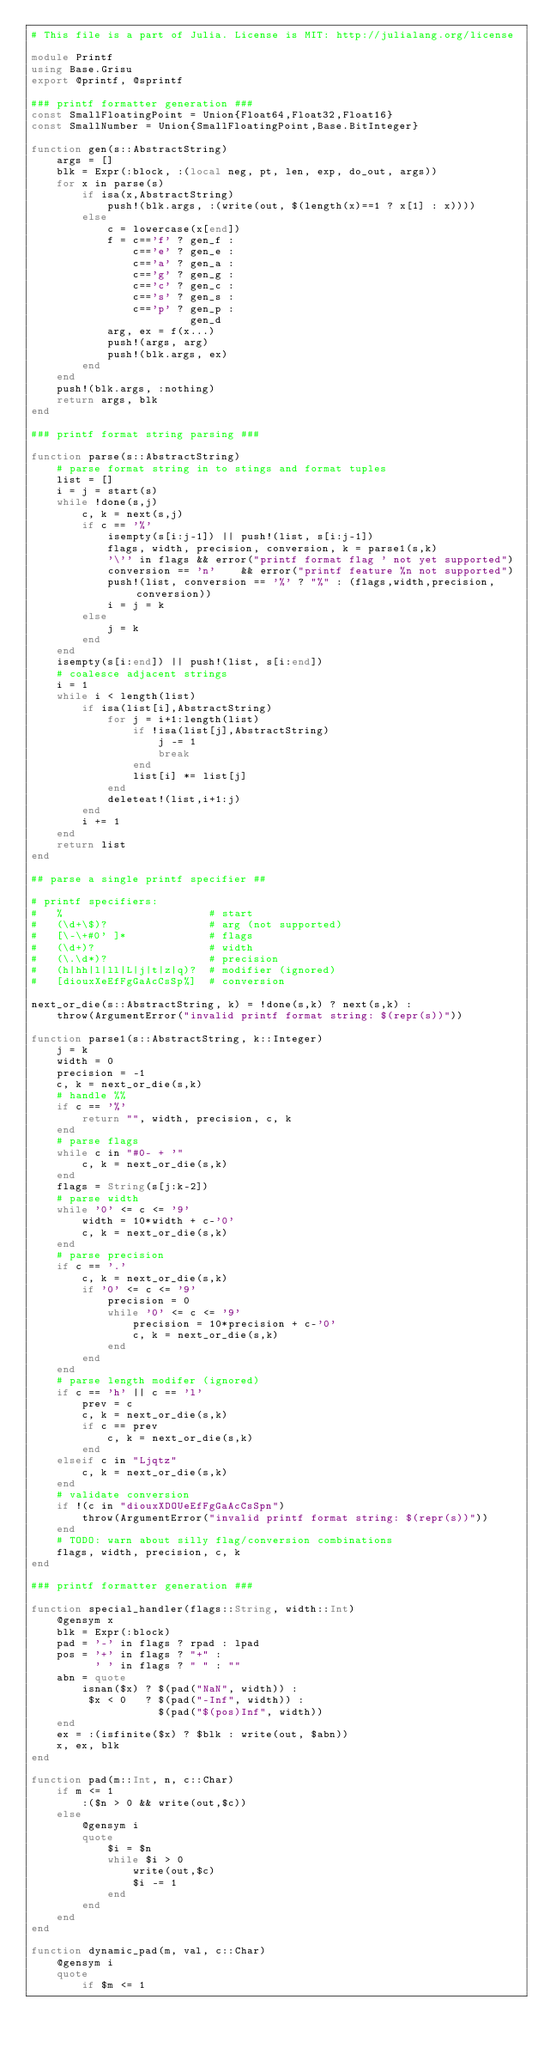<code> <loc_0><loc_0><loc_500><loc_500><_Julia_># This file is a part of Julia. License is MIT: http://julialang.org/license

module Printf
using Base.Grisu
export @printf, @sprintf

### printf formatter generation ###
const SmallFloatingPoint = Union{Float64,Float32,Float16}
const SmallNumber = Union{SmallFloatingPoint,Base.BitInteger}

function gen(s::AbstractString)
    args = []
    blk = Expr(:block, :(local neg, pt, len, exp, do_out, args))
    for x in parse(s)
        if isa(x,AbstractString)
            push!(blk.args, :(write(out, $(length(x)==1 ? x[1] : x))))
        else
            c = lowercase(x[end])
            f = c=='f' ? gen_f :
                c=='e' ? gen_e :
                c=='a' ? gen_a :
                c=='g' ? gen_g :
                c=='c' ? gen_c :
                c=='s' ? gen_s :
                c=='p' ? gen_p :
                         gen_d
            arg, ex = f(x...)
            push!(args, arg)
            push!(blk.args, ex)
        end
    end
    push!(blk.args, :nothing)
    return args, blk
end

### printf format string parsing ###

function parse(s::AbstractString)
    # parse format string in to stings and format tuples
    list = []
    i = j = start(s)
    while !done(s,j)
        c, k = next(s,j)
        if c == '%'
            isempty(s[i:j-1]) || push!(list, s[i:j-1])
            flags, width, precision, conversion, k = parse1(s,k)
            '\'' in flags && error("printf format flag ' not yet supported")
            conversion == 'n'    && error("printf feature %n not supported")
            push!(list, conversion == '%' ? "%" : (flags,width,precision,conversion))
            i = j = k
        else
            j = k
        end
    end
    isempty(s[i:end]) || push!(list, s[i:end])
    # coalesce adjacent strings
    i = 1
    while i < length(list)
        if isa(list[i],AbstractString)
            for j = i+1:length(list)
                if !isa(list[j],AbstractString)
                    j -= 1
                    break
                end
                list[i] *= list[j]
            end
            deleteat!(list,i+1:j)
        end
        i += 1
    end
    return list
end

## parse a single printf specifier ##

# printf specifiers:
#   %                       # start
#   (\d+\$)?                # arg (not supported)
#   [\-\+#0' ]*             # flags
#   (\d+)?                  # width
#   (\.\d*)?                # precision
#   (h|hh|l|ll|L|j|t|z|q)?  # modifier (ignored)
#   [diouxXeEfFgGaAcCsSp%]  # conversion

next_or_die(s::AbstractString, k) = !done(s,k) ? next(s,k) :
    throw(ArgumentError("invalid printf format string: $(repr(s))"))

function parse1(s::AbstractString, k::Integer)
    j = k
    width = 0
    precision = -1
    c, k = next_or_die(s,k)
    # handle %%
    if c == '%'
        return "", width, precision, c, k
    end
    # parse flags
    while c in "#0- + '"
        c, k = next_or_die(s,k)
    end
    flags = String(s[j:k-2])
    # parse width
    while '0' <= c <= '9'
        width = 10*width + c-'0'
        c, k = next_or_die(s,k)
    end
    # parse precision
    if c == '.'
        c, k = next_or_die(s,k)
        if '0' <= c <= '9'
            precision = 0
            while '0' <= c <= '9'
                precision = 10*precision + c-'0'
                c, k = next_or_die(s,k)
            end
        end
    end
    # parse length modifer (ignored)
    if c == 'h' || c == 'l'
        prev = c
        c, k = next_or_die(s,k)
        if c == prev
            c, k = next_or_die(s,k)
        end
    elseif c in "Ljqtz"
        c, k = next_or_die(s,k)
    end
    # validate conversion
    if !(c in "diouxXDOUeEfFgGaAcCsSpn")
        throw(ArgumentError("invalid printf format string: $(repr(s))"))
    end
    # TODO: warn about silly flag/conversion combinations
    flags, width, precision, c, k
end

### printf formatter generation ###

function special_handler(flags::String, width::Int)
    @gensym x
    blk = Expr(:block)
    pad = '-' in flags ? rpad : lpad
    pos = '+' in flags ? "+" :
          ' ' in flags ? " " : ""
    abn = quote
        isnan($x) ? $(pad("NaN", width)) :
         $x < 0   ? $(pad("-Inf", width)) :
                    $(pad("$(pos)Inf", width))
    end
    ex = :(isfinite($x) ? $blk : write(out, $abn))
    x, ex, blk
end

function pad(m::Int, n, c::Char)
    if m <= 1
        :($n > 0 && write(out,$c))
    else
        @gensym i
        quote
            $i = $n
            while $i > 0
                write(out,$c)
                $i -= 1
            end
        end
    end
end

function dynamic_pad(m, val, c::Char)
    @gensym i
    quote
        if $m <= 1</code> 